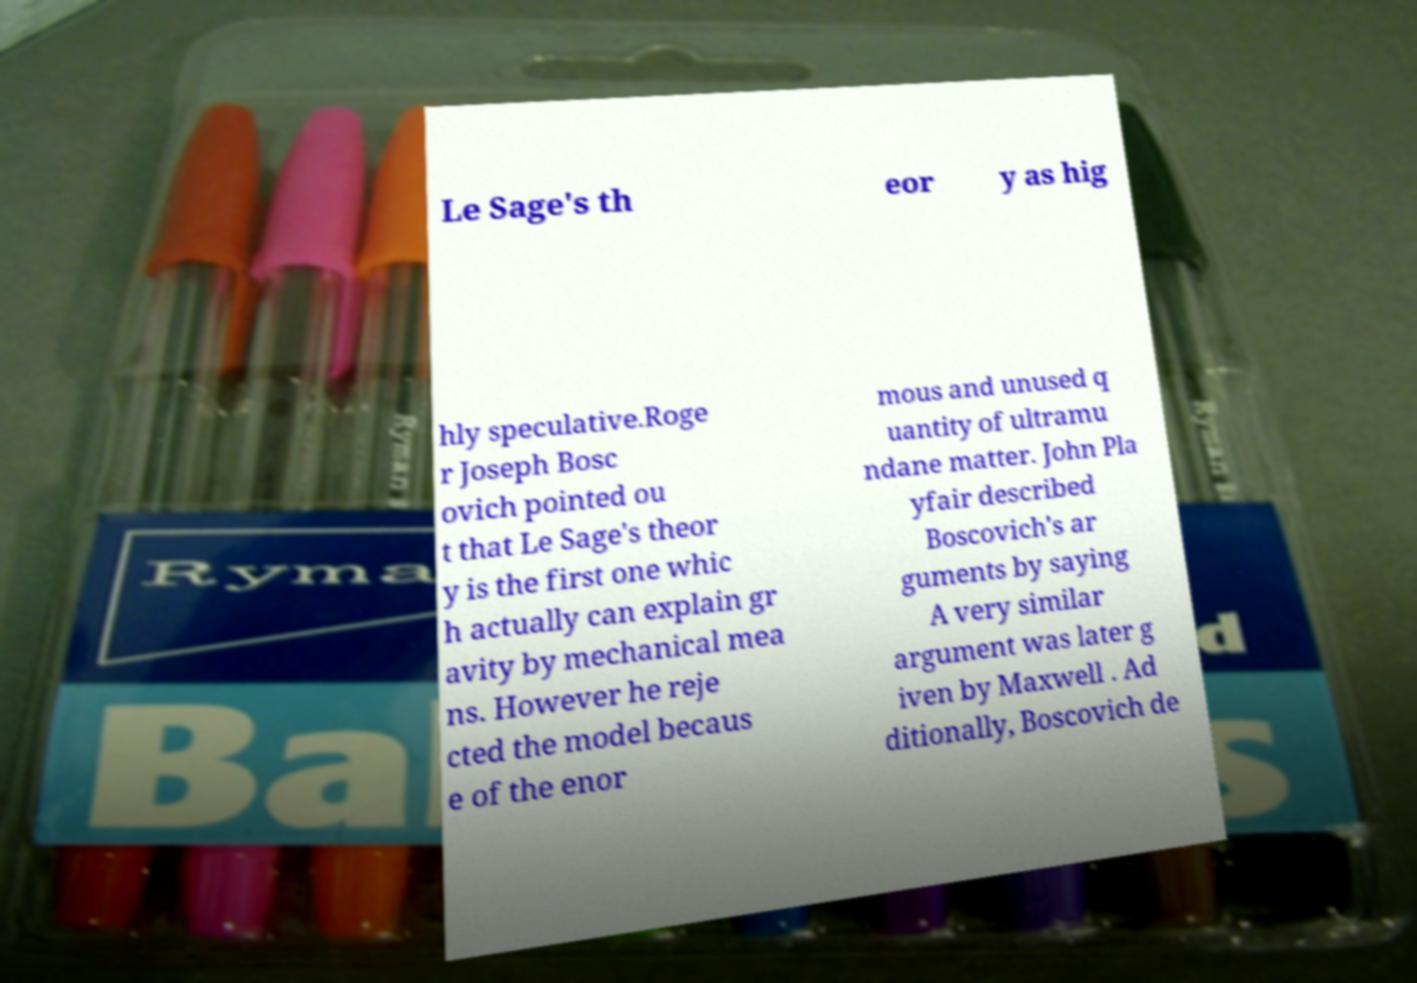Could you extract and type out the text from this image? Le Sage's th eor y as hig hly speculative.Roge r Joseph Bosc ovich pointed ou t that Le Sage's theor y is the first one whic h actually can explain gr avity by mechanical mea ns. However he reje cted the model becaus e of the enor mous and unused q uantity of ultramu ndane matter. John Pla yfair described Boscovich's ar guments by saying A very similar argument was later g iven by Maxwell . Ad ditionally, Boscovich de 